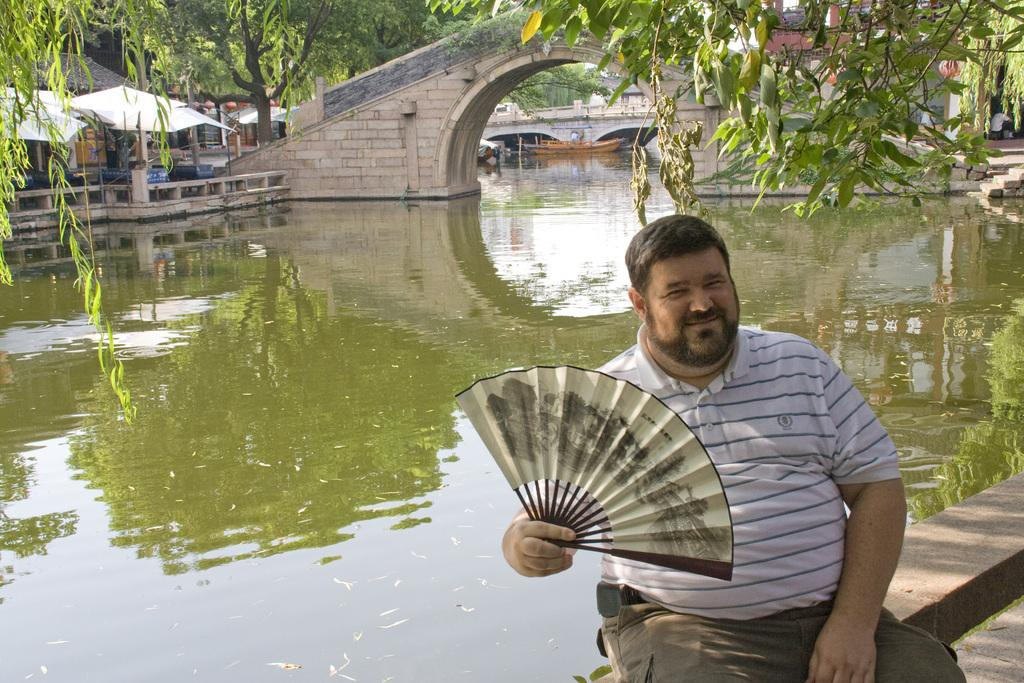What is the man in the image holding? The man is holding a folding fan. What can be seen in the background of the image? There are trees, a bridge, a board, and houses in the background of the image. Is there any water visible in the image? Yes, there is water visible in the image. What type of lace can be seen on the man's clothing in the image? There is no lace visible on the man's clothing in the image. What is the position of the chain in the image? There is no chain present in the image. 